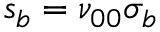<formula> <loc_0><loc_0><loc_500><loc_500>s _ { b } = \nu _ { 0 0 } \sigma _ { b }</formula> 